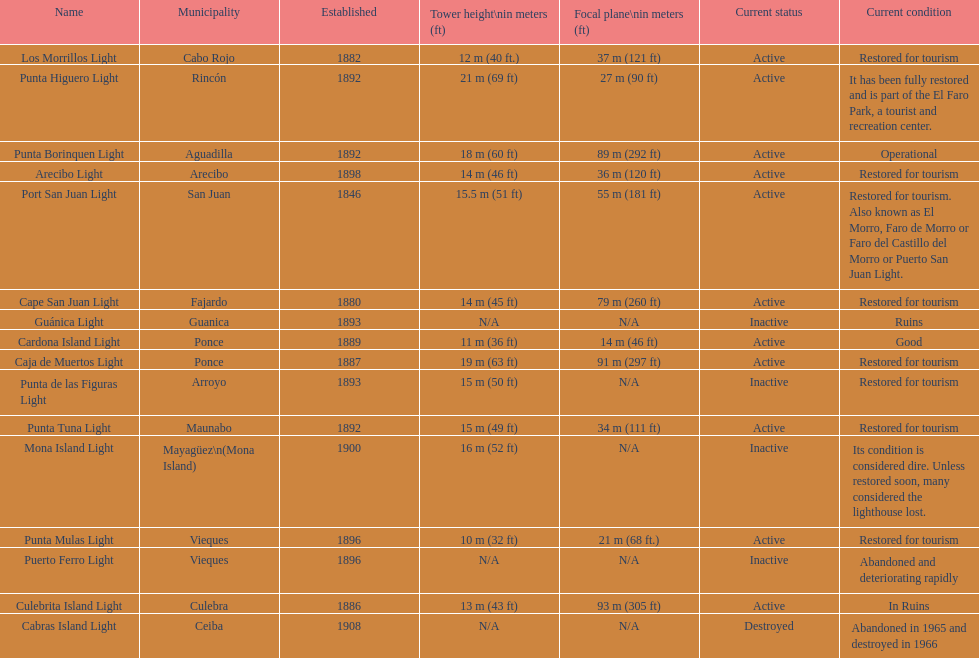How many towers stand 18 meters tall or more? 3. 